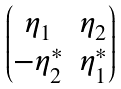Convert formula to latex. <formula><loc_0><loc_0><loc_500><loc_500>\begin{pmatrix} \eta _ { 1 } & \eta _ { 2 } \\ - \eta _ { 2 } ^ { * } & \eta _ { 1 } ^ { * } \end{pmatrix}</formula> 